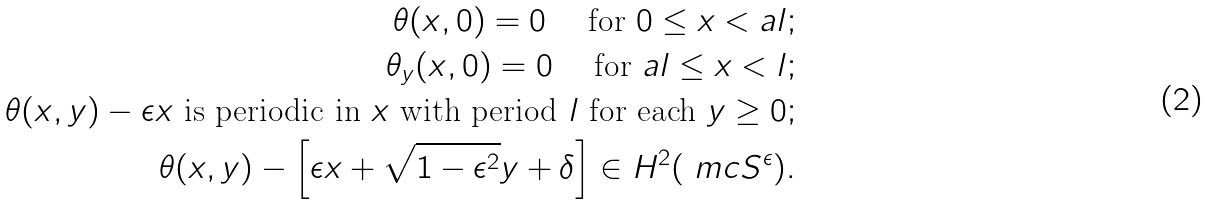Convert formula to latex. <formula><loc_0><loc_0><loc_500><loc_500>\theta ( x , 0 ) = 0 \quad \text { for } 0 \leq x < a l ; \\ \theta _ { y } ( x , 0 ) = 0 \quad \text { for } a l \leq x < l ; \\ \theta ( x , y ) - \epsilon x \text { is periodic in $x$ with period $l$ for each } y \geq 0 ; \\ \theta ( x , y ) - \left [ \epsilon x + \sqrt { 1 - \epsilon ^ { 2 } } y + \delta \right ] \in H ^ { 2 } ( \ m c { S } ^ { \epsilon } ) .</formula> 